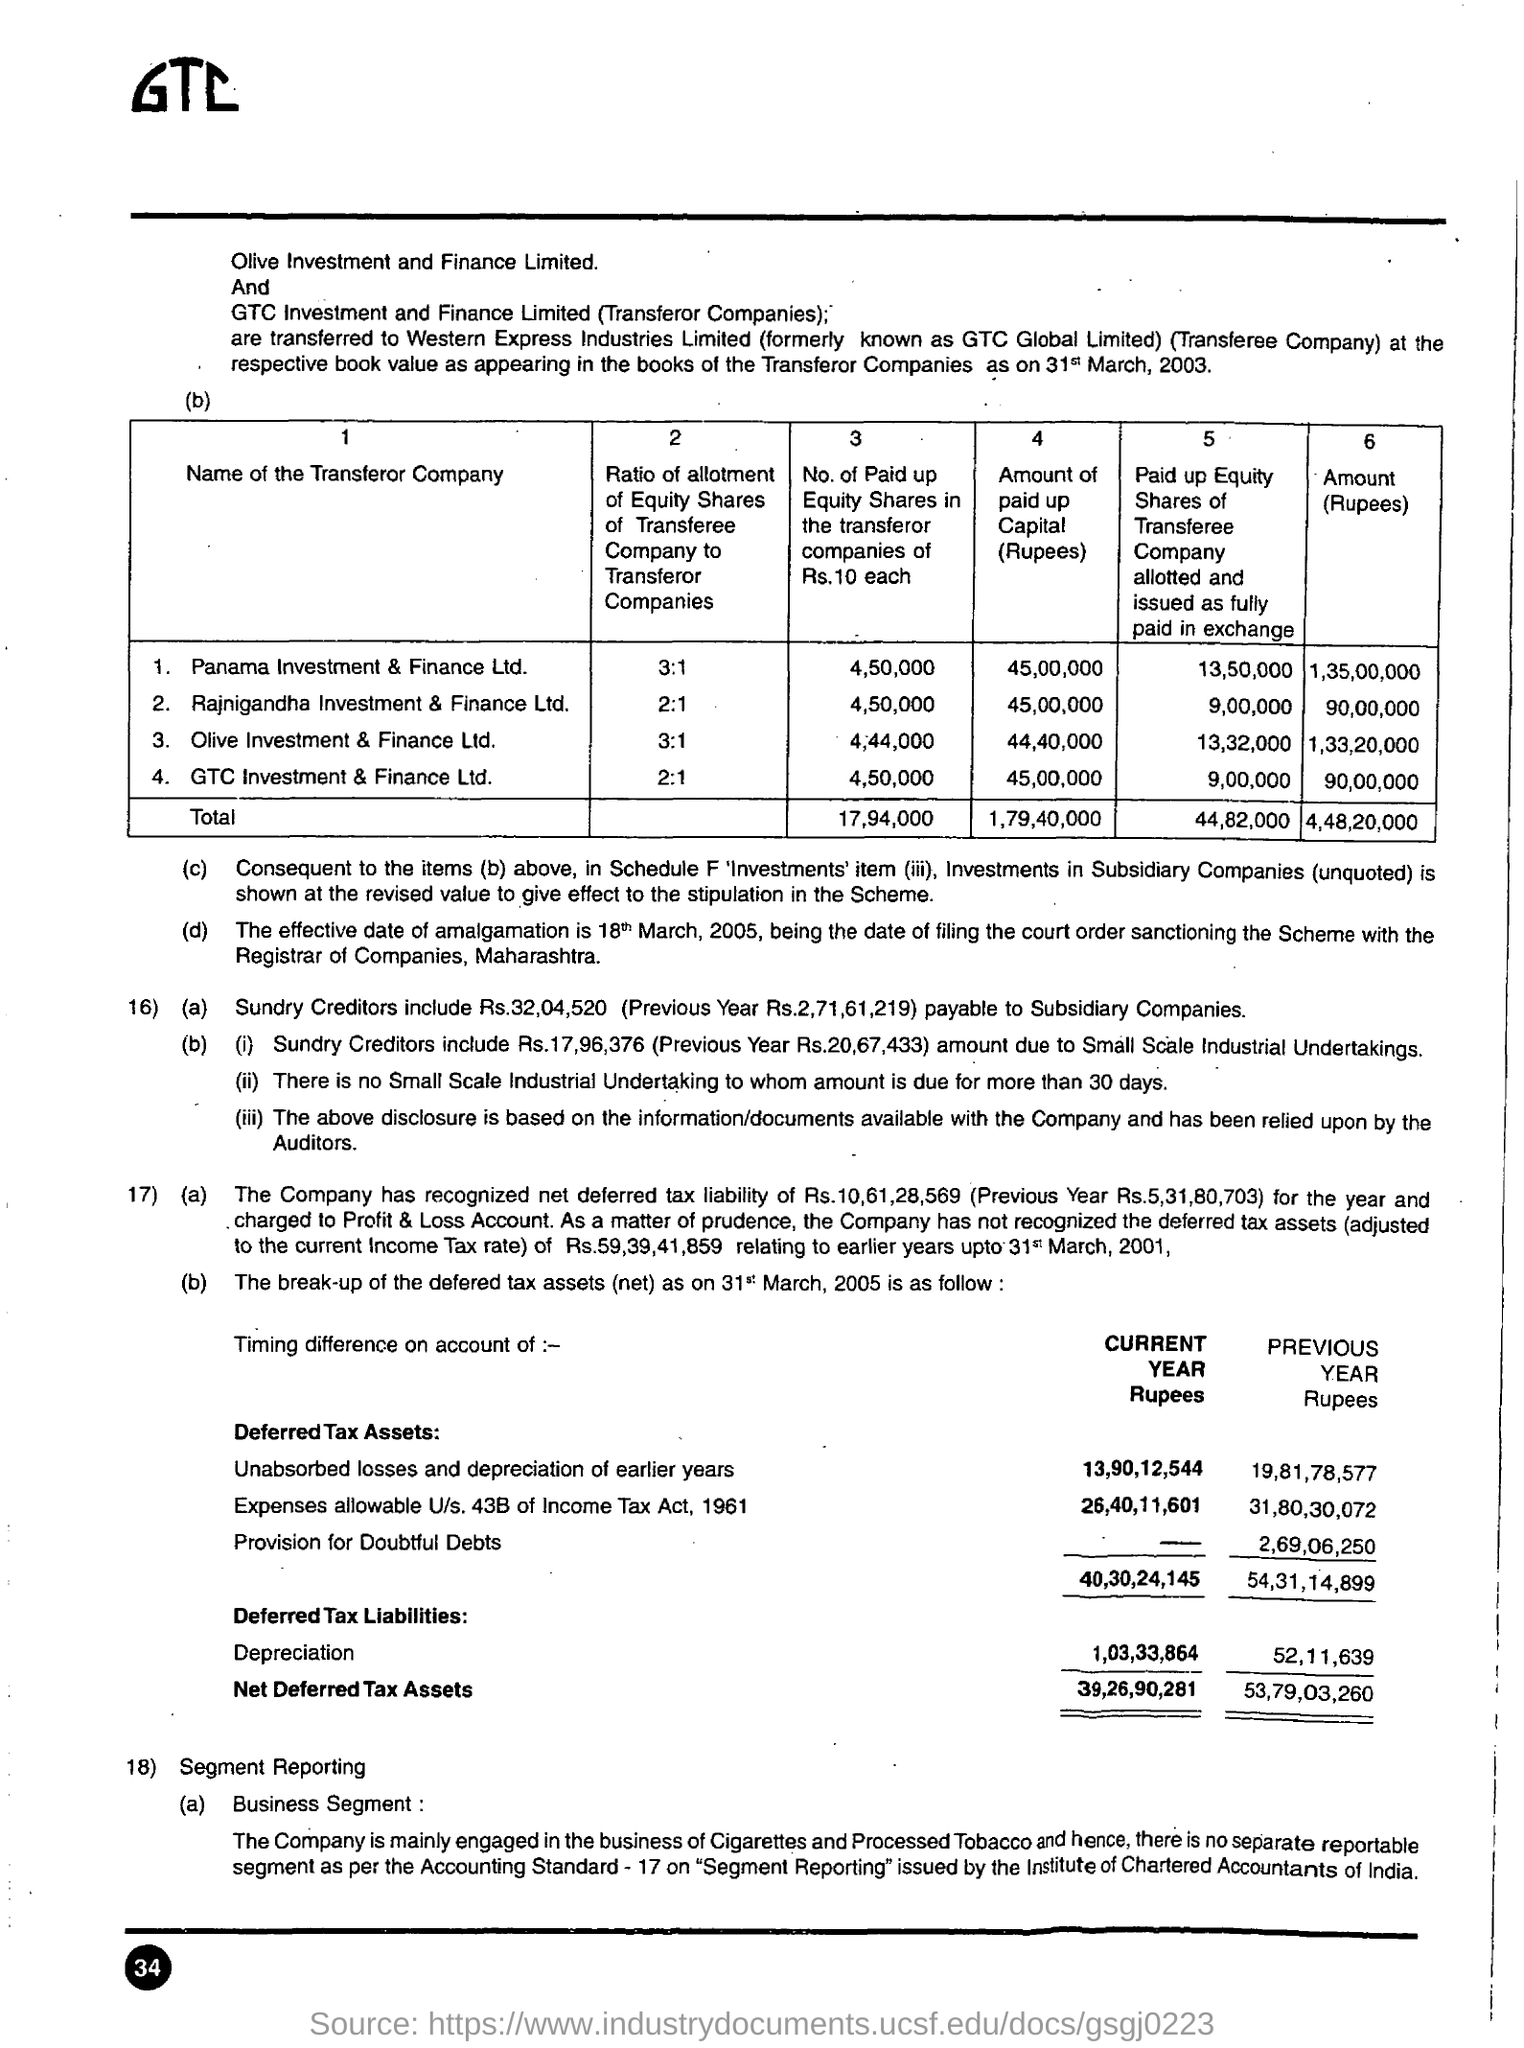Draw attention to some important aspects in this diagram. The text written in the top left is "What is the text written in the top left? GTC..". 